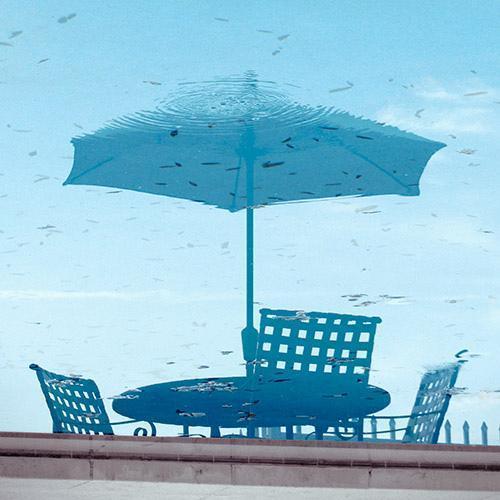How many chairs are there?
Give a very brief answer. 3. 